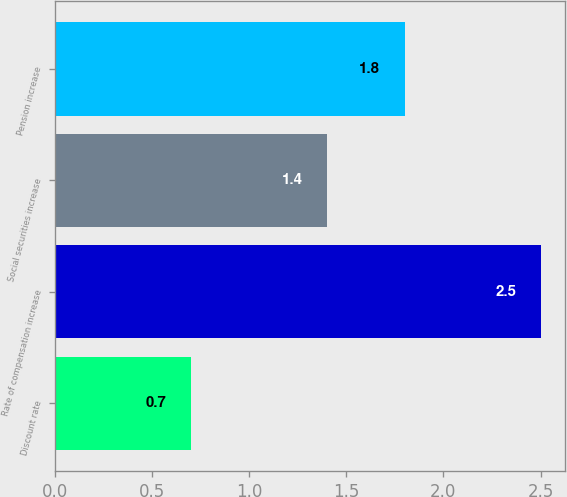<chart> <loc_0><loc_0><loc_500><loc_500><bar_chart><fcel>Discount rate<fcel>Rate of compensation increase<fcel>Social securities increase<fcel>Pension increase<nl><fcel>0.7<fcel>2.5<fcel>1.4<fcel>1.8<nl></chart> 